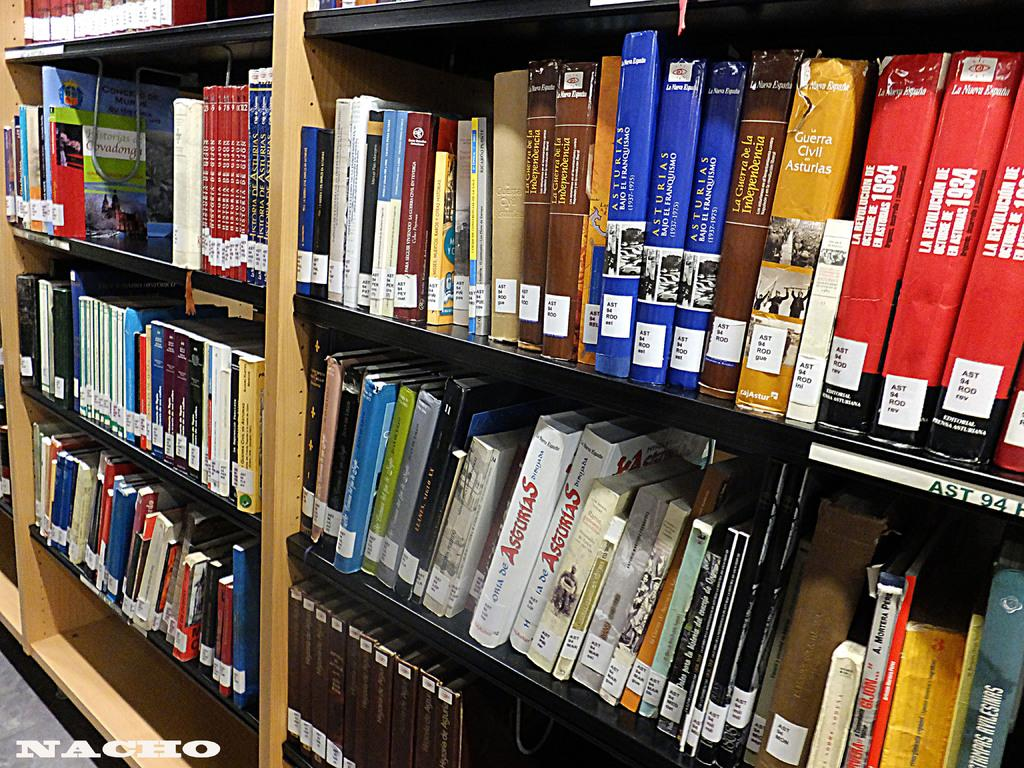<image>
Relay a brief, clear account of the picture shown. Library shelves full of books with the bottom left shelf empty, and it says Nacho in the corner. 